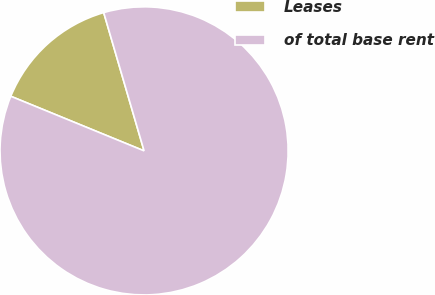Convert chart to OTSL. <chart><loc_0><loc_0><loc_500><loc_500><pie_chart><fcel>Leases<fcel>of total base rent<nl><fcel>14.29%<fcel>85.71%<nl></chart> 